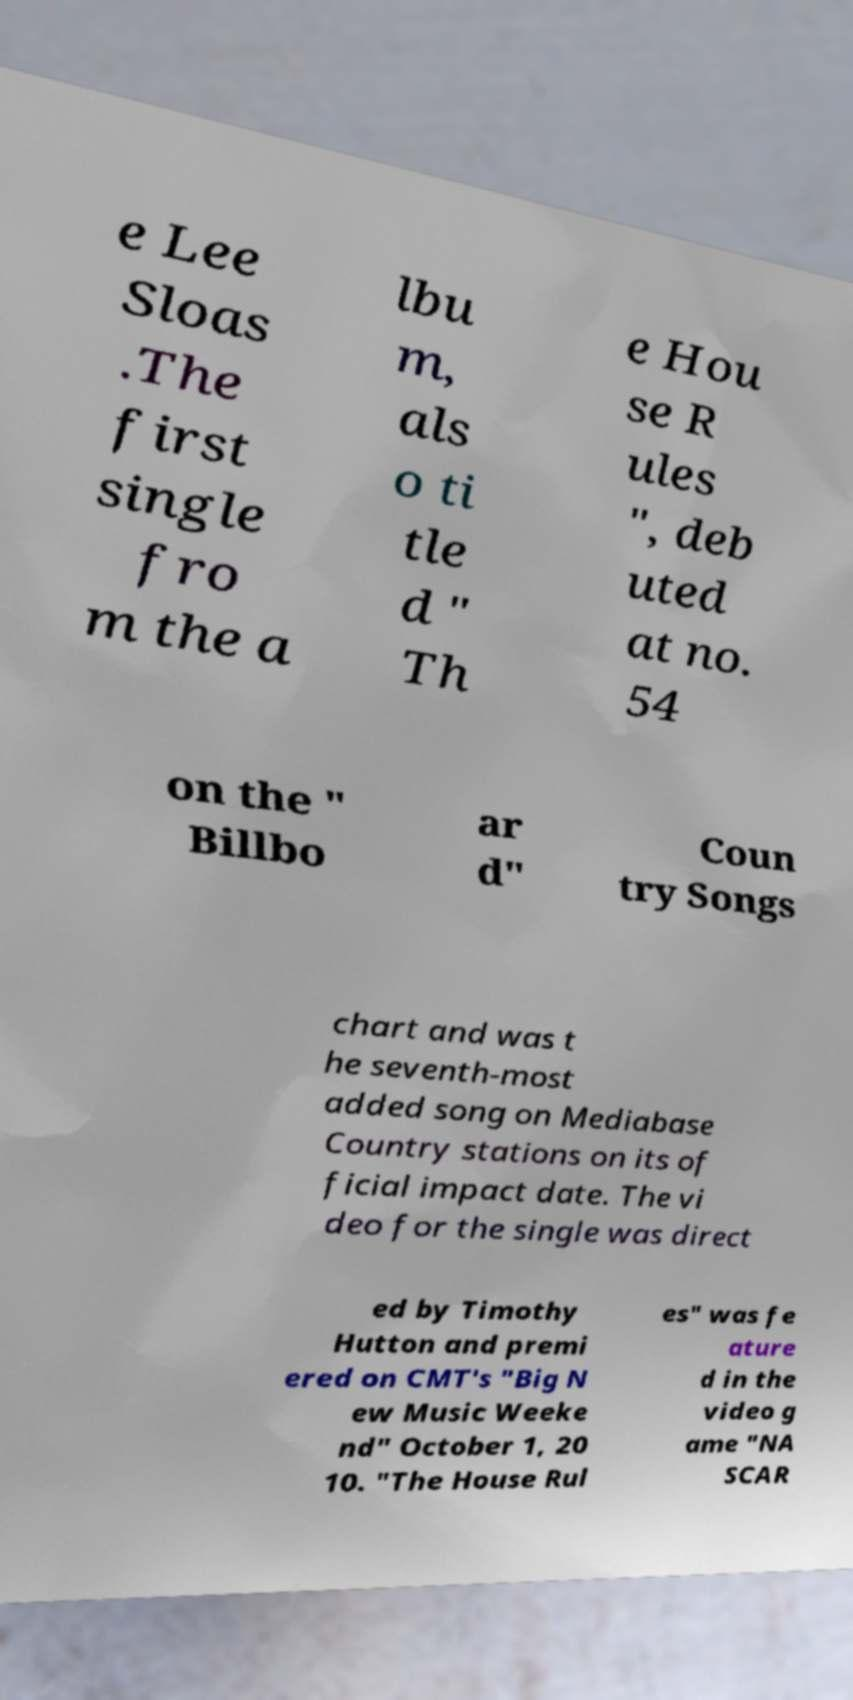Can you accurately transcribe the text from the provided image for me? e Lee Sloas .The first single fro m the a lbu m, als o ti tle d " Th e Hou se R ules ", deb uted at no. 54 on the " Billbo ar d" Coun try Songs chart and was t he seventh-most added song on Mediabase Country stations on its of ficial impact date. The vi deo for the single was direct ed by Timothy Hutton and premi ered on CMT's "Big N ew Music Weeke nd" October 1, 20 10. "The House Rul es" was fe ature d in the video g ame "NA SCAR 